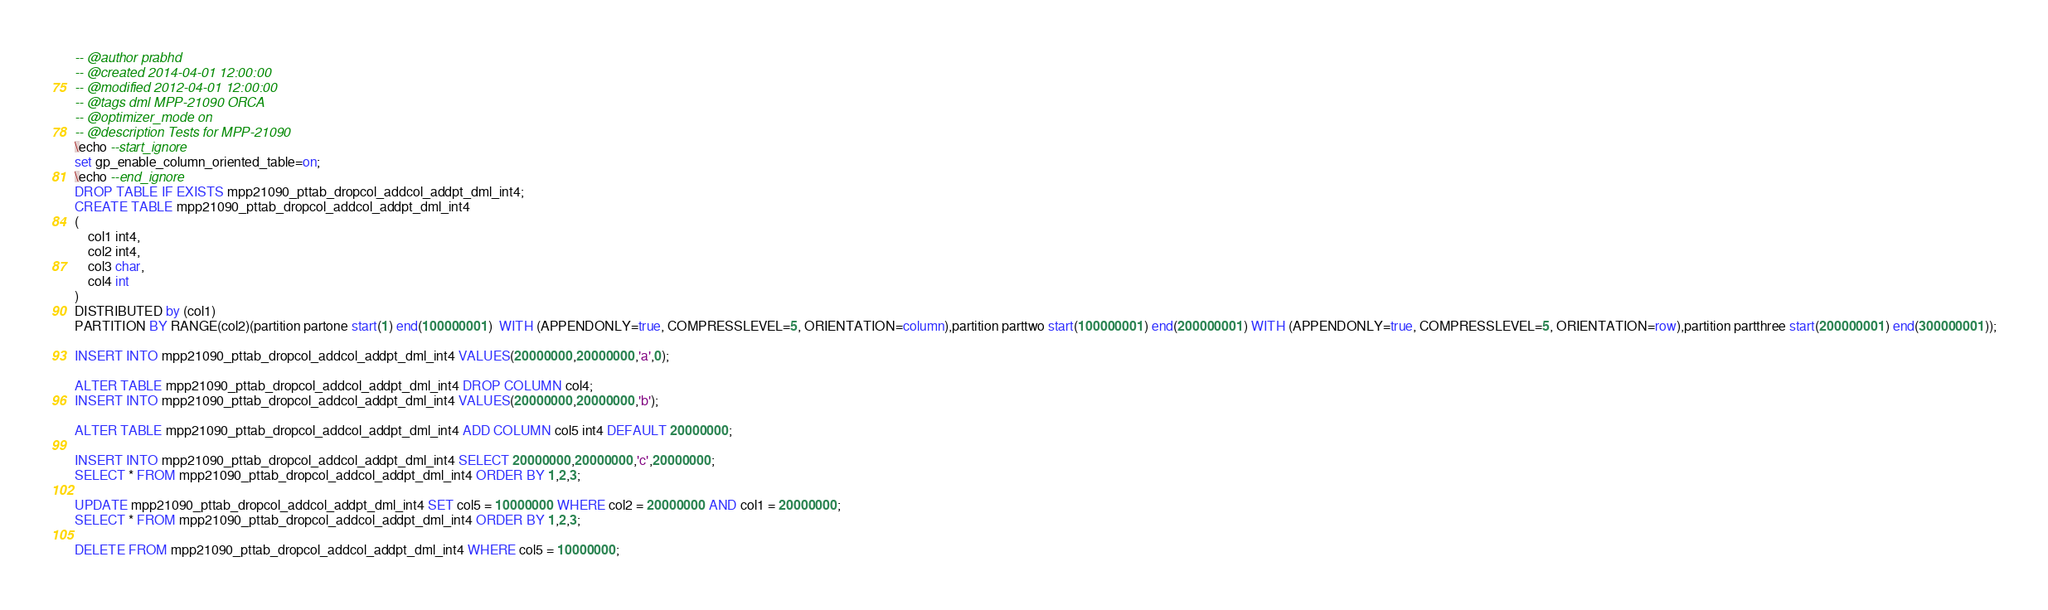Convert code to text. <code><loc_0><loc_0><loc_500><loc_500><_SQL_>-- @author prabhd 
-- @created 2014-04-01 12:00:00
-- @modified 2012-04-01 12:00:00
-- @tags dml MPP-21090 ORCA
-- @optimizer_mode on	
-- @description Tests for MPP-21090
\echo --start_ignore
set gp_enable_column_oriented_table=on;
\echo --end_ignore
DROP TABLE IF EXISTS mpp21090_pttab_dropcol_addcol_addpt_dml_int4;
CREATE TABLE mpp21090_pttab_dropcol_addcol_addpt_dml_int4
(
    col1 int4,
    col2 int4,
    col3 char,
    col4 int
) 
DISTRIBUTED by (col1)
PARTITION BY RANGE(col2)(partition partone start(1) end(100000001)  WITH (APPENDONLY=true, COMPRESSLEVEL=5, ORIENTATION=column),partition parttwo start(100000001) end(200000001) WITH (APPENDONLY=true, COMPRESSLEVEL=5, ORIENTATION=row),partition partthree start(200000001) end(300000001));

INSERT INTO mpp21090_pttab_dropcol_addcol_addpt_dml_int4 VALUES(20000000,20000000,'a',0);

ALTER TABLE mpp21090_pttab_dropcol_addcol_addpt_dml_int4 DROP COLUMN col4;
INSERT INTO mpp21090_pttab_dropcol_addcol_addpt_dml_int4 VALUES(20000000,20000000,'b');

ALTER TABLE mpp21090_pttab_dropcol_addcol_addpt_dml_int4 ADD COLUMN col5 int4 DEFAULT 20000000;

INSERT INTO mpp21090_pttab_dropcol_addcol_addpt_dml_int4 SELECT 20000000,20000000,'c',20000000;
SELECT * FROM mpp21090_pttab_dropcol_addcol_addpt_dml_int4 ORDER BY 1,2,3;

UPDATE mpp21090_pttab_dropcol_addcol_addpt_dml_int4 SET col5 = 10000000 WHERE col2 = 20000000 AND col1 = 20000000;
SELECT * FROM mpp21090_pttab_dropcol_addcol_addpt_dml_int4 ORDER BY 1,2,3;

DELETE FROM mpp21090_pttab_dropcol_addcol_addpt_dml_int4 WHERE col5 = 10000000;</code> 